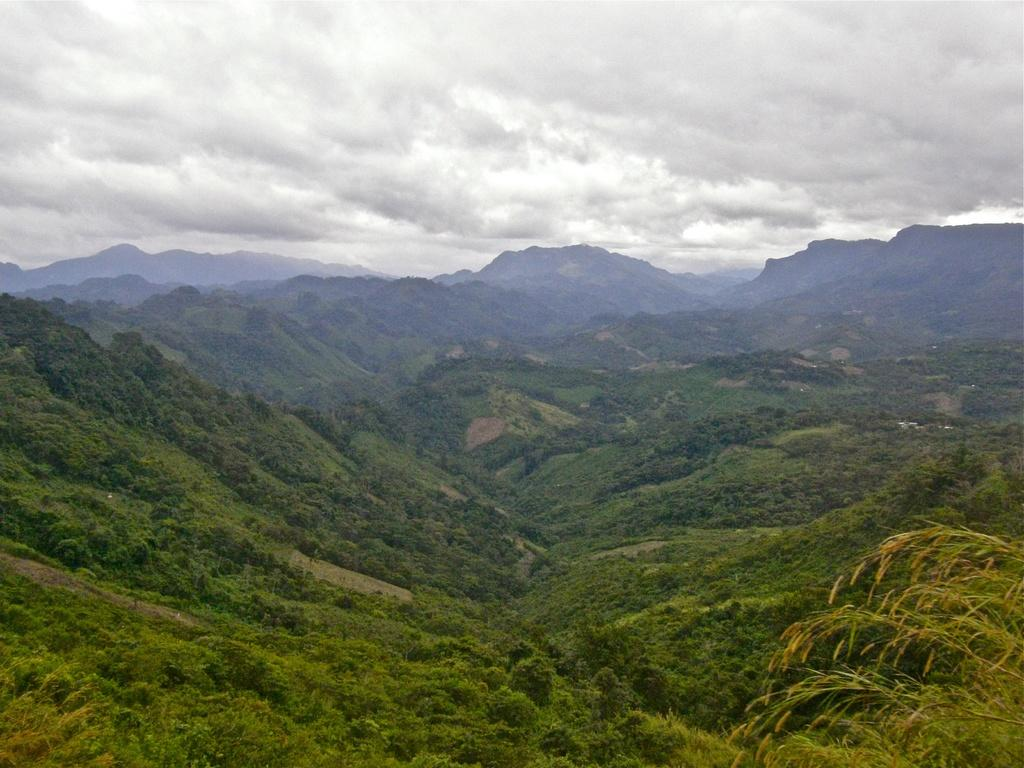What type of natural formation can be seen in the image? There are mountains in the image. What vegetation is present on the mountains? There are plants and trees on the mountains. What is visible at the top of the mountains? The sky is visible at the top of the mountains. Who is the owner of the wool on the mountains in the image? There is no wool present in the image, and therefore no owner can be identified. 